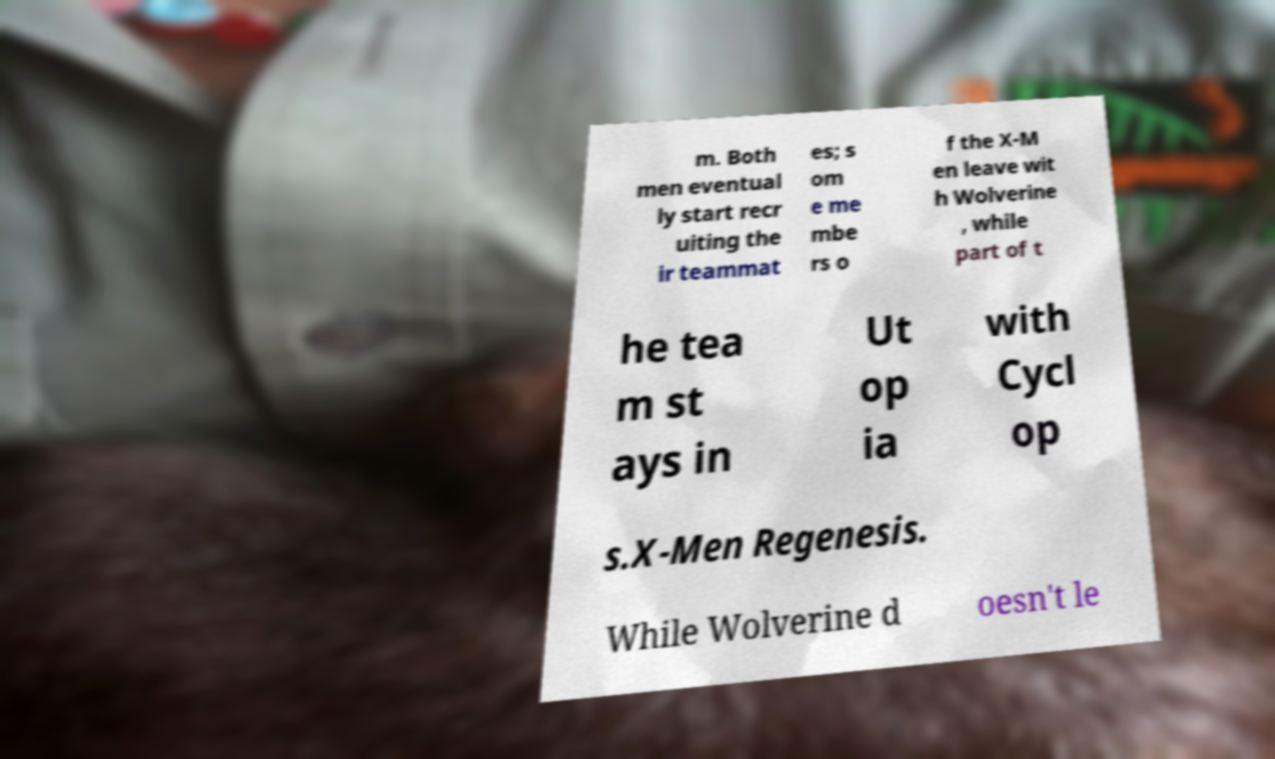Could you extract and type out the text from this image? m. Both men eventual ly start recr uiting the ir teammat es; s om e me mbe rs o f the X-M en leave wit h Wolverine , while part of t he tea m st ays in Ut op ia with Cycl op s.X-Men Regenesis. While Wolverine d oesn't le 